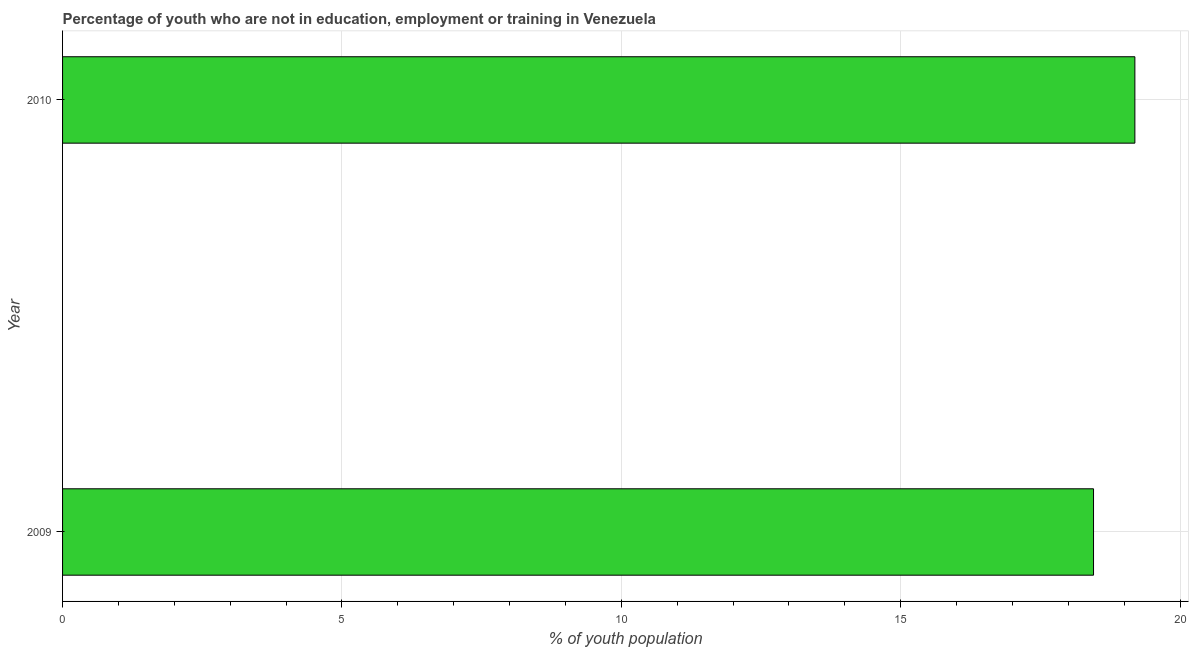Does the graph contain grids?
Your answer should be compact. Yes. What is the title of the graph?
Offer a very short reply. Percentage of youth who are not in education, employment or training in Venezuela. What is the label or title of the X-axis?
Offer a terse response. % of youth population. What is the unemployed youth population in 2009?
Your answer should be compact. 18.45. Across all years, what is the maximum unemployed youth population?
Offer a terse response. 19.19. Across all years, what is the minimum unemployed youth population?
Provide a succinct answer. 18.45. In which year was the unemployed youth population minimum?
Provide a short and direct response. 2009. What is the sum of the unemployed youth population?
Keep it short and to the point. 37.64. What is the difference between the unemployed youth population in 2009 and 2010?
Your answer should be very brief. -0.74. What is the average unemployed youth population per year?
Your answer should be compact. 18.82. What is the median unemployed youth population?
Ensure brevity in your answer.  18.82. In how many years, is the unemployed youth population greater than 1 %?
Ensure brevity in your answer.  2. In how many years, is the unemployed youth population greater than the average unemployed youth population taken over all years?
Ensure brevity in your answer.  1. How many bars are there?
Your answer should be very brief. 2. Are the values on the major ticks of X-axis written in scientific E-notation?
Provide a short and direct response. No. What is the % of youth population of 2009?
Keep it short and to the point. 18.45. What is the % of youth population in 2010?
Ensure brevity in your answer.  19.19. What is the difference between the % of youth population in 2009 and 2010?
Ensure brevity in your answer.  -0.74. 